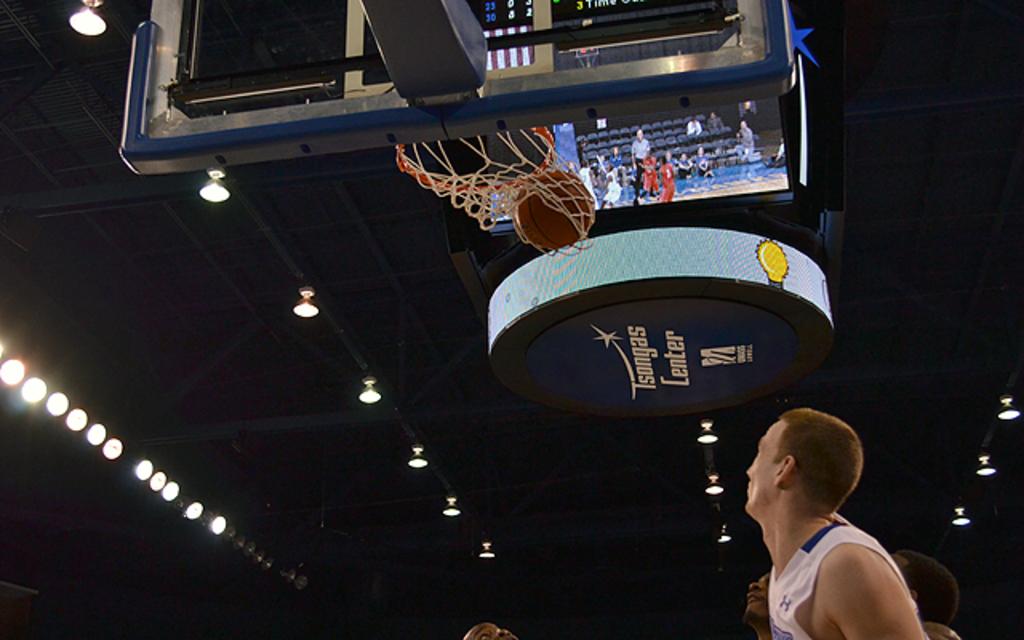What is the arena name below the monitors?
Offer a very short reply. Tsongas center. What color letters are shown?
Offer a terse response. White. 